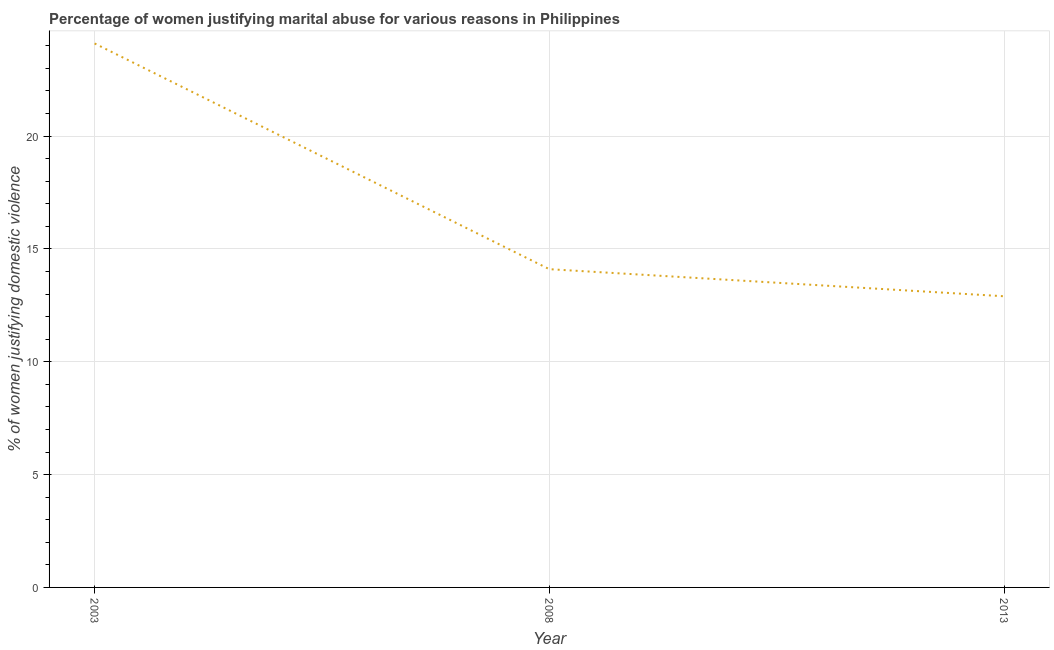What is the percentage of women justifying marital abuse in 2003?
Your answer should be very brief. 24.1. Across all years, what is the maximum percentage of women justifying marital abuse?
Keep it short and to the point. 24.1. In which year was the percentage of women justifying marital abuse maximum?
Keep it short and to the point. 2003. What is the sum of the percentage of women justifying marital abuse?
Your answer should be very brief. 51.1. What is the difference between the percentage of women justifying marital abuse in 2003 and 2013?
Give a very brief answer. 11.2. What is the average percentage of women justifying marital abuse per year?
Keep it short and to the point. 17.03. What is the median percentage of women justifying marital abuse?
Make the answer very short. 14.1. In how many years, is the percentage of women justifying marital abuse greater than 11 %?
Your answer should be very brief. 3. Do a majority of the years between 2013 and 2003 (inclusive) have percentage of women justifying marital abuse greater than 6 %?
Provide a succinct answer. No. What is the ratio of the percentage of women justifying marital abuse in 2003 to that in 2013?
Provide a short and direct response. 1.87. Is the difference between the percentage of women justifying marital abuse in 2008 and 2013 greater than the difference between any two years?
Your answer should be very brief. No. What is the difference between the highest and the second highest percentage of women justifying marital abuse?
Your answer should be compact. 10. What is the difference between the highest and the lowest percentage of women justifying marital abuse?
Ensure brevity in your answer.  11.2. Does the percentage of women justifying marital abuse monotonically increase over the years?
Provide a succinct answer. No. How many years are there in the graph?
Ensure brevity in your answer.  3. Does the graph contain any zero values?
Make the answer very short. No. Does the graph contain grids?
Offer a very short reply. Yes. What is the title of the graph?
Your response must be concise. Percentage of women justifying marital abuse for various reasons in Philippines. What is the label or title of the Y-axis?
Provide a short and direct response. % of women justifying domestic violence. What is the % of women justifying domestic violence of 2003?
Provide a succinct answer. 24.1. What is the difference between the % of women justifying domestic violence in 2003 and 2008?
Provide a succinct answer. 10. What is the difference between the % of women justifying domestic violence in 2008 and 2013?
Ensure brevity in your answer.  1.2. What is the ratio of the % of women justifying domestic violence in 2003 to that in 2008?
Give a very brief answer. 1.71. What is the ratio of the % of women justifying domestic violence in 2003 to that in 2013?
Your answer should be compact. 1.87. What is the ratio of the % of women justifying domestic violence in 2008 to that in 2013?
Provide a succinct answer. 1.09. 